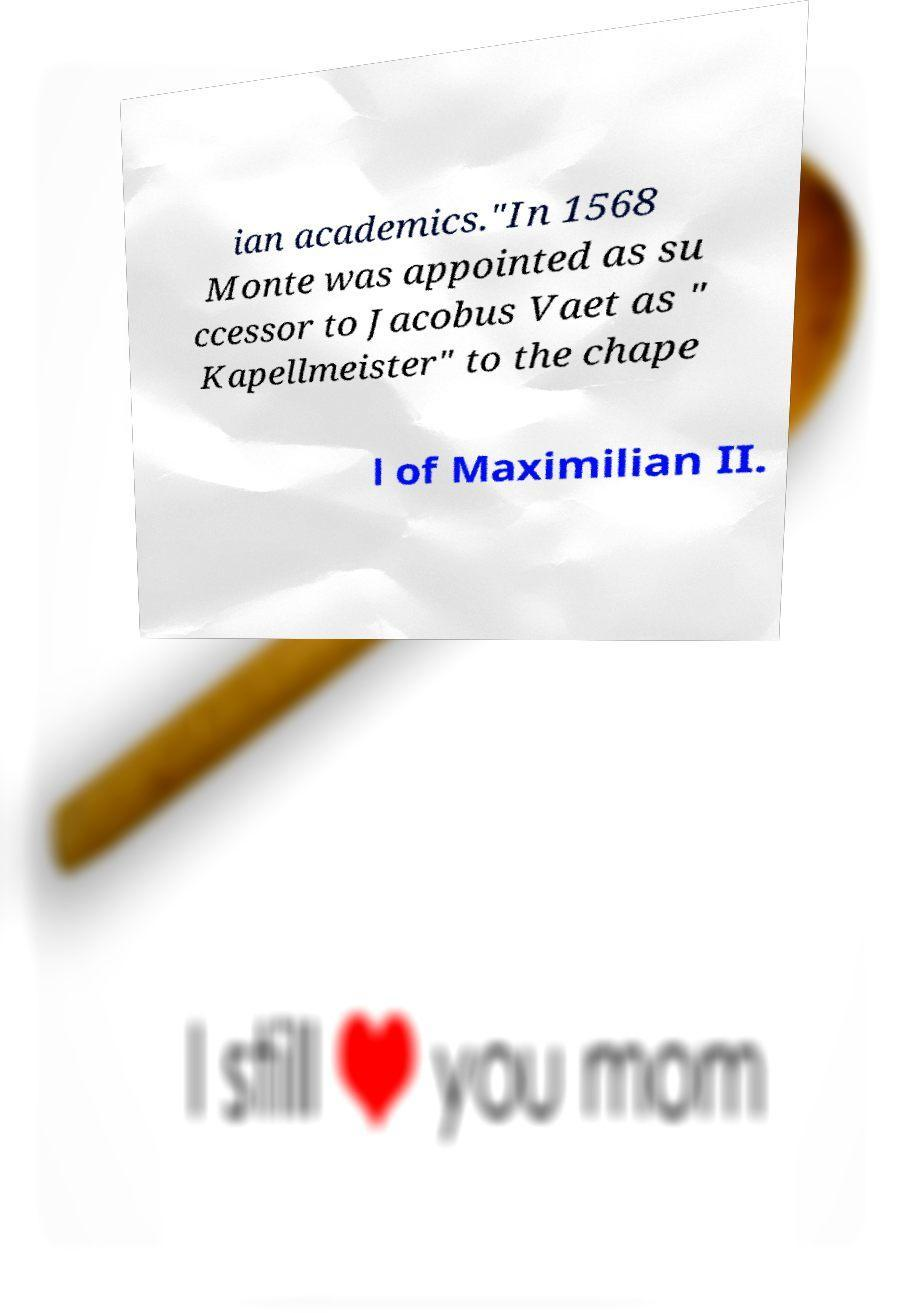Could you assist in decoding the text presented in this image and type it out clearly? ian academics."In 1568 Monte was appointed as su ccessor to Jacobus Vaet as " Kapellmeister" to the chape l of Maximilian II. 